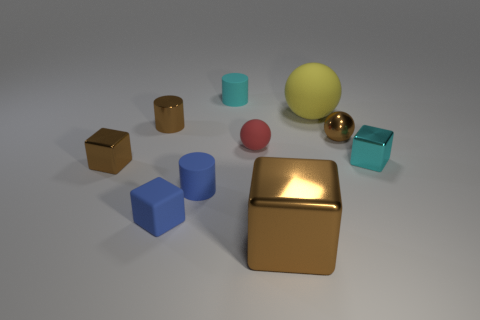Is the shape of the red object the same as the tiny brown object that is on the right side of the yellow thing?
Give a very brief answer. Yes. What size is the matte cylinder behind the red thing?
Offer a very short reply. Small. What is the material of the big brown object?
Keep it short and to the point. Metal. Is the shape of the small cyan object right of the big matte thing the same as  the yellow matte object?
Offer a very short reply. No. There is a shiny ball that is the same color as the shiny cylinder; what size is it?
Ensure brevity in your answer.  Small. Is there a brown cylinder that has the same size as the cyan rubber thing?
Your answer should be very brief. Yes. Is there a block that is on the right side of the small matte cylinder that is behind the tiny cylinder that is in front of the cyan cube?
Your response must be concise. Yes. Do the rubber block and the rubber cylinder that is in front of the yellow ball have the same color?
Provide a succinct answer. Yes. What material is the tiny sphere that is to the right of the big block that is on the right side of the cyan object that is behind the large yellow sphere made of?
Ensure brevity in your answer.  Metal. There is a cyan thing that is on the left side of the tiny red thing; what is its shape?
Ensure brevity in your answer.  Cylinder. 